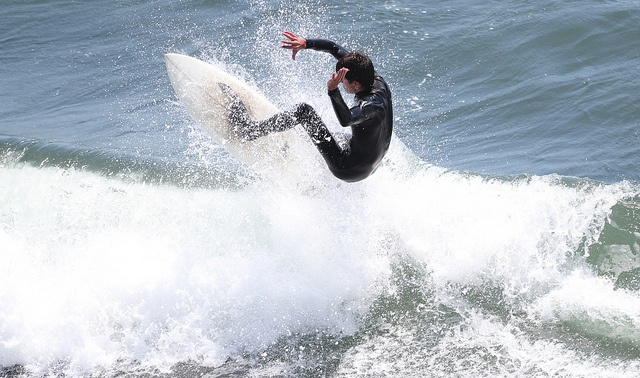Describe the objects in this image and their specific colors. I can see surfboard in gray, lightgray, and darkgray tones and people in gray, black, darkgray, and lightgray tones in this image. 